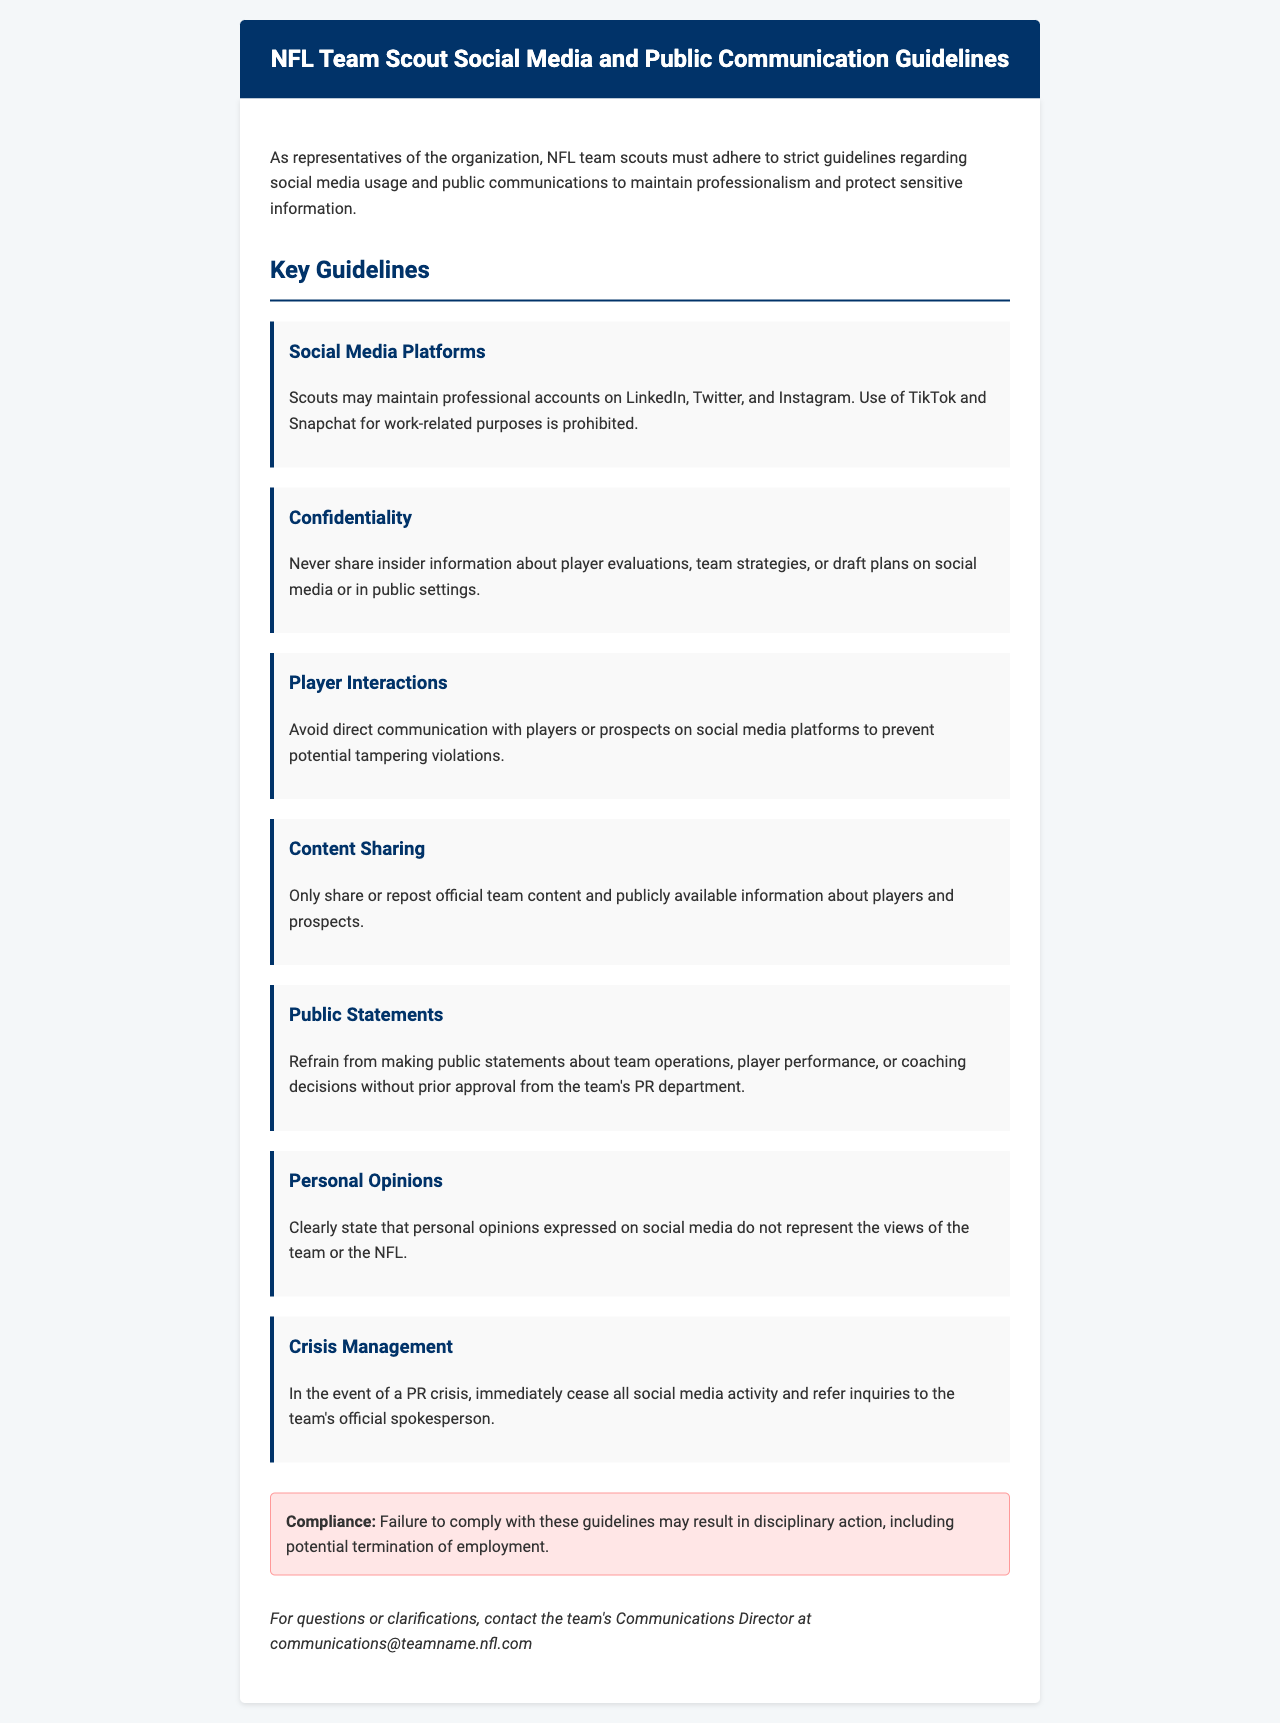What social media platforms can scouts use? The document lists LinkedIn, Twitter, and Instagram as platforms scouts may maintain professional accounts on.
Answer: LinkedIn, Twitter, Instagram What is prohibited regarding TikTok and Snapchat? The document states that the use of TikTok and Snapchat for work-related purposes is prohibited.
Answer: Prohibited What must scouts avoid when communicating with players? The document advises scouts to avoid direct communication with players or prospects on social media platforms to prevent potential tampering violations.
Answer: Direct communication What type of content can scouts share? Scouts can only share or repost official team content and publicly available information about players and prospects.
Answer: Official team content Who must approve public statements made by scouts? Approval must come from the team's PR department before making public statements about team operations, player performance, or coaching decisions.
Answer: Team's PR department What should scouts do during a PR crisis? In the event of a PR crisis, scouts should immediately cease all social media activity and refer inquiries to the team's official spokesperson.
Answer: Cease all social media activity What is the consequence of failing to comply with guidelines? The document states that failure to comply may result in disciplinary action, including potential termination of employment.
Answer: Disciplinary action How can scouts get clarification on the guidelines? The document provides a contact method for questions or clarifications through the team's Communications Director.
Answer: Communications Director What does the document define as personal opinions? Personal opinions expressed on social media should be clearly stated as not representing the views of the team or the NFL.
Answer: Not representing views What is the overall purpose of these guidelines? The purpose is to maintain professionalism and protect sensitive information as representatives of the organization.
Answer: Maintain professionalism 